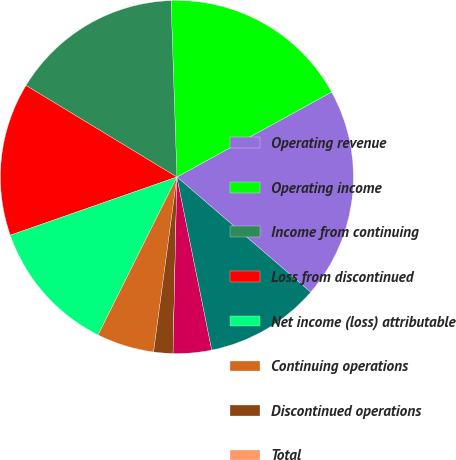<chart> <loc_0><loc_0><loc_500><loc_500><pie_chart><fcel>Operating revenue<fcel>Operating income<fcel>Income from continuing<fcel>Loss from discontinued<fcel>Net income (loss) attributable<fcel>Continuing operations<fcel>Discontinued operations<fcel>Total<fcel>Dividends declared per share<fcel>High<nl><fcel>19.3%<fcel>17.54%<fcel>15.79%<fcel>14.03%<fcel>12.28%<fcel>5.26%<fcel>1.76%<fcel>0.0%<fcel>3.51%<fcel>10.53%<nl></chart> 